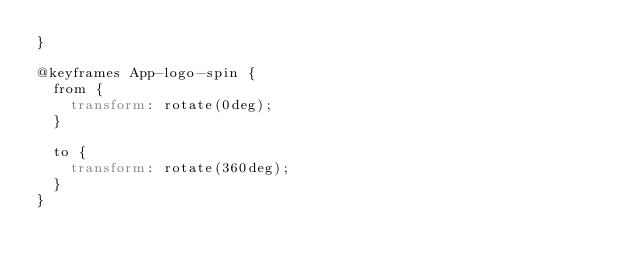Convert code to text. <code><loc_0><loc_0><loc_500><loc_500><_CSS_>}

@keyframes App-logo-spin {
  from {
    transform: rotate(0deg);
  }

  to {
    transform: rotate(360deg);
  }
}</code> 